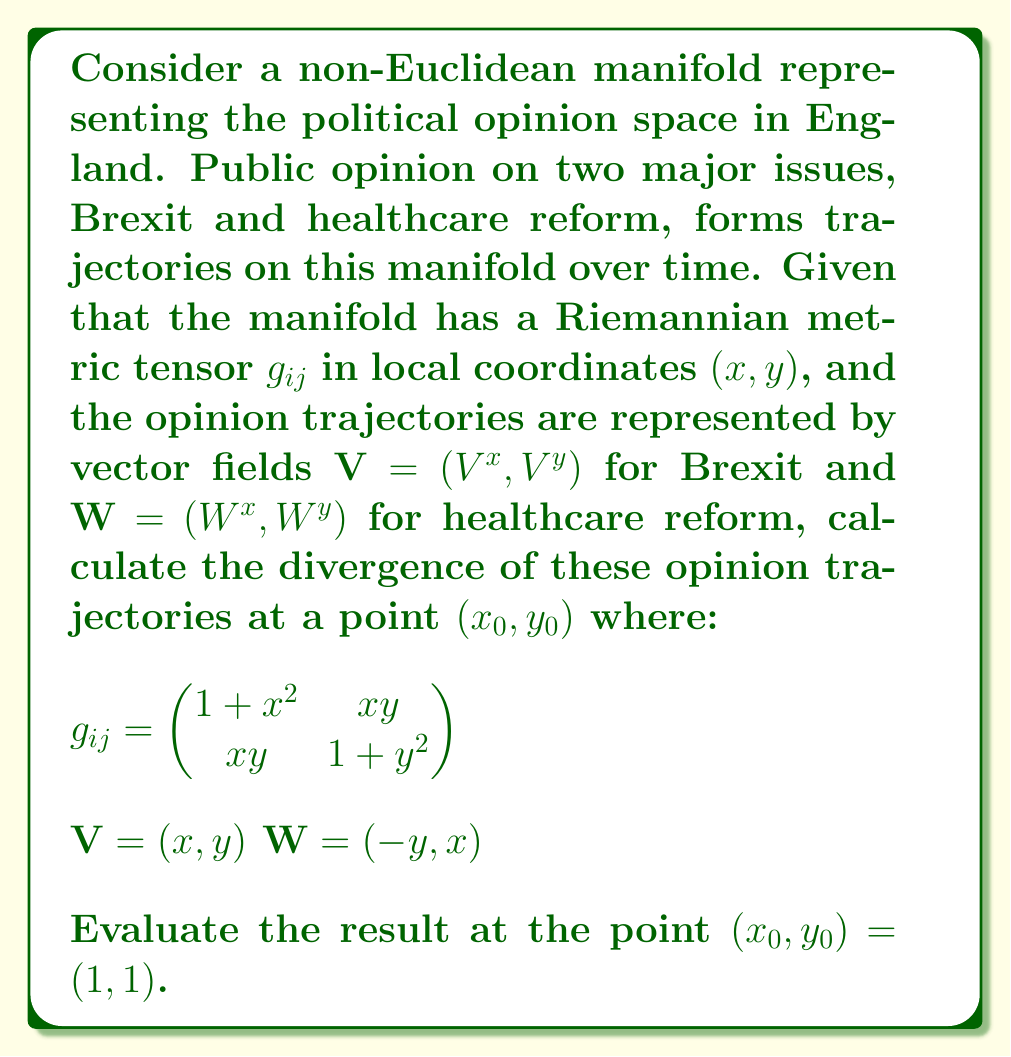Teach me how to tackle this problem. To solve this problem, we need to calculate the divergence of the vector fields $\mathbf{V}$ and $\mathbf{W}$ on the given non-Euclidean manifold. The divergence in a Riemannian manifold is given by:

$$\text{div}(\mathbf{X}) = \frac{1}{\sqrt{|g|}} \frac{\partial}{\partial x^i}(\sqrt{|g|}X^i)$$

Where $|g|$ is the determinant of the metric tensor, and we sum over repeated indices.

Step 1: Calculate $|g|$
$$|g| = (1+x^2)(1+y^2) - (xy)^2 = 1 + x^2 + y^2 + x^2y^2 - x^2y^2 = 1 + x^2 + y^2$$

Step 2: Calculate $\sqrt{|g|}$
$$\sqrt{|g|} = \sqrt{1 + x^2 + y^2}$$

Step 3: Calculate the divergence of $\mathbf{V}$
$$\begin{align}
\text{div}(\mathbf{V}) &= \frac{1}{\sqrt{1 + x^2 + y^2}} \left[\frac{\partial}{\partial x}(\sqrt{1 + x^2 + y^2} \cdot x) + \frac{\partial}{\partial y}(\sqrt{1 + x^2 + y^2} \cdot y)\right] \\
&= \frac{1}{\sqrt{1 + x^2 + y^2}} \left[\frac{x^2}{\sqrt{1 + x^2 + y^2}} + \sqrt{1 + x^2 + y^2} + \frac{y^2}{\sqrt{1 + x^2 + y^2}} + \sqrt{1 + x^2 + y^2}\right] \\
&= \frac{x^2 + y^2}{1 + x^2 + y^2} + 2
\end{align}$$

Step 4: Calculate the divergence of $\mathbf{W}$
$$\begin{align}
\text{div}(\mathbf{W}) &= \frac{1}{\sqrt{1 + x^2 + y^2}} \left[\frac{\partial}{\partial x}(\sqrt{1 + x^2 + y^2} \cdot (-y)) + \frac{\partial}{\partial y}(\sqrt{1 + x^2 + y^2} \cdot x)\right] \\
&= \frac{1}{\sqrt{1 + x^2 + y^2}} \left[-\frac{xy}{\sqrt{1 + x^2 + y^2}} + \frac{xy}{\sqrt{1 + x^2 + y^2}}\right] \\
&= 0
\end{align}$$

Step 5: Evaluate at the point $(x_0, y_0) = (1, 1)$
For $\mathbf{V}$:
$$\text{div}(\mathbf{V})_{(1,1)} = \frac{1^2 + 1^2}{1 + 1^2 + 1^2} + 2 = \frac{2}{3} + 2 = \frac{8}{3}$$

For $\mathbf{W}$:
$$\text{div}(\mathbf{W})_{(1,1)} = 0$$

The total divergence is the sum of these two values:
$$\text{Total Divergence} = \frac{8}{3} + 0 = \frac{8}{3}$$
Answer: The divergence of the public opinion trajectories at the point $(1, 1)$ is $\frac{8}{3}$. 